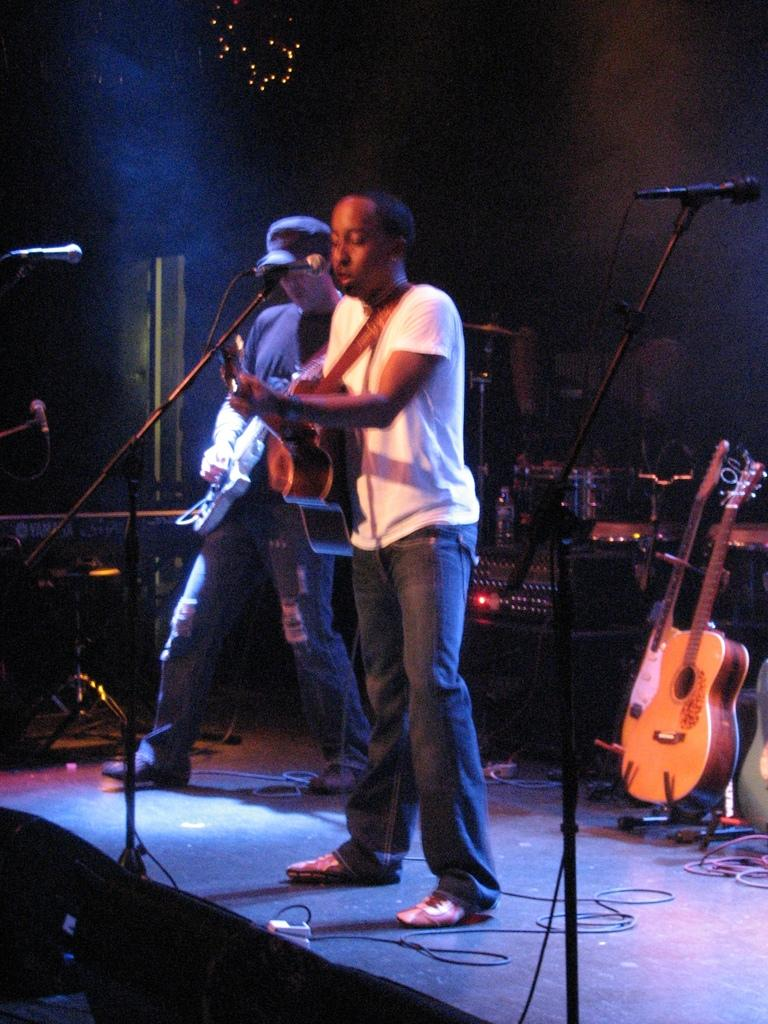How many people are in the image? There are two guys in the image. What are the guys doing in the image? The guys are playing guitars. How are the guys holding the guitars? The guys are holding guitars in their hands. What is in front of the guys? There is a microphone in front of the guys. What can be seen in the background of the image? There are guitars and equipment hire in the background of the image. What type of zinc is present in the image? There is no zinc present in the image. What color is the vest worn by one of the guys in the image? There is no vest visible in the image. 